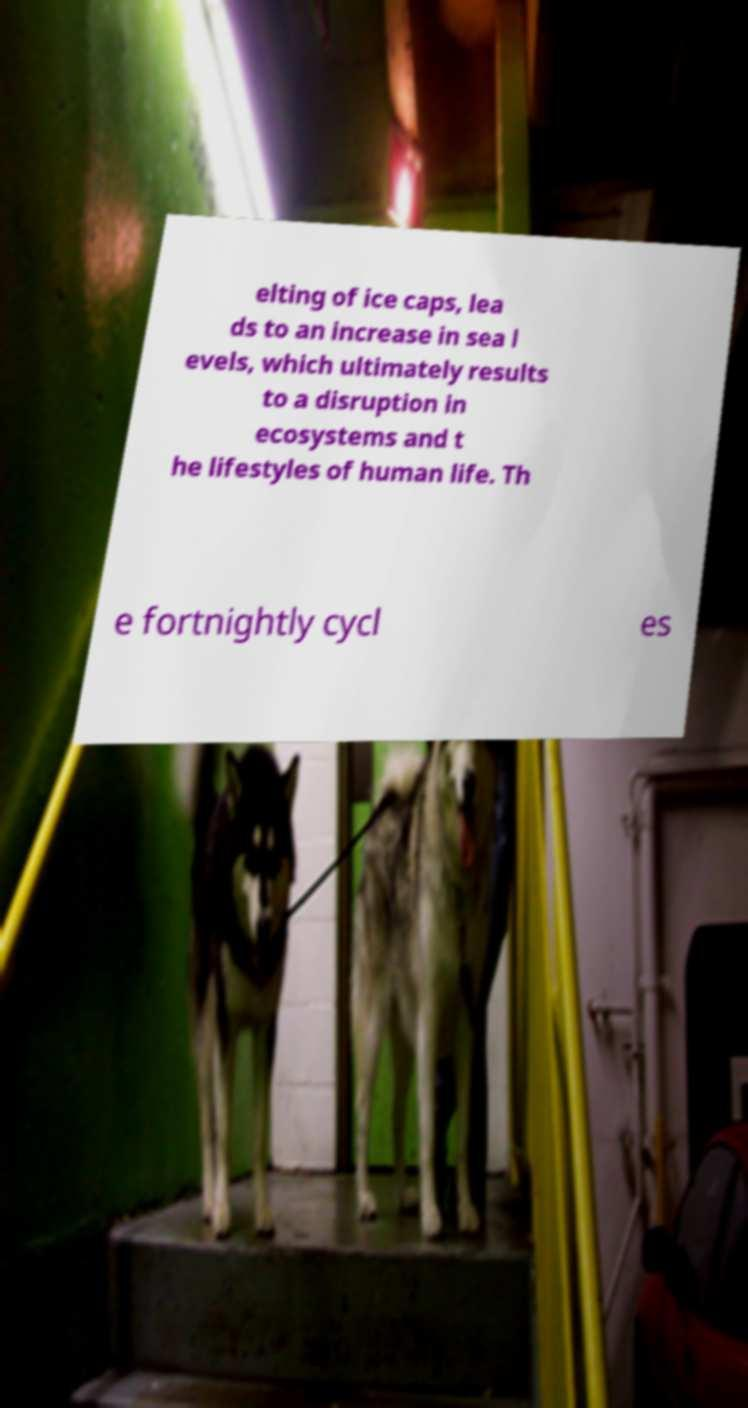Please identify and transcribe the text found in this image. elting of ice caps, lea ds to an increase in sea l evels, which ultimately results to a disruption in ecosystems and t he lifestyles of human life. Th e fortnightly cycl es 